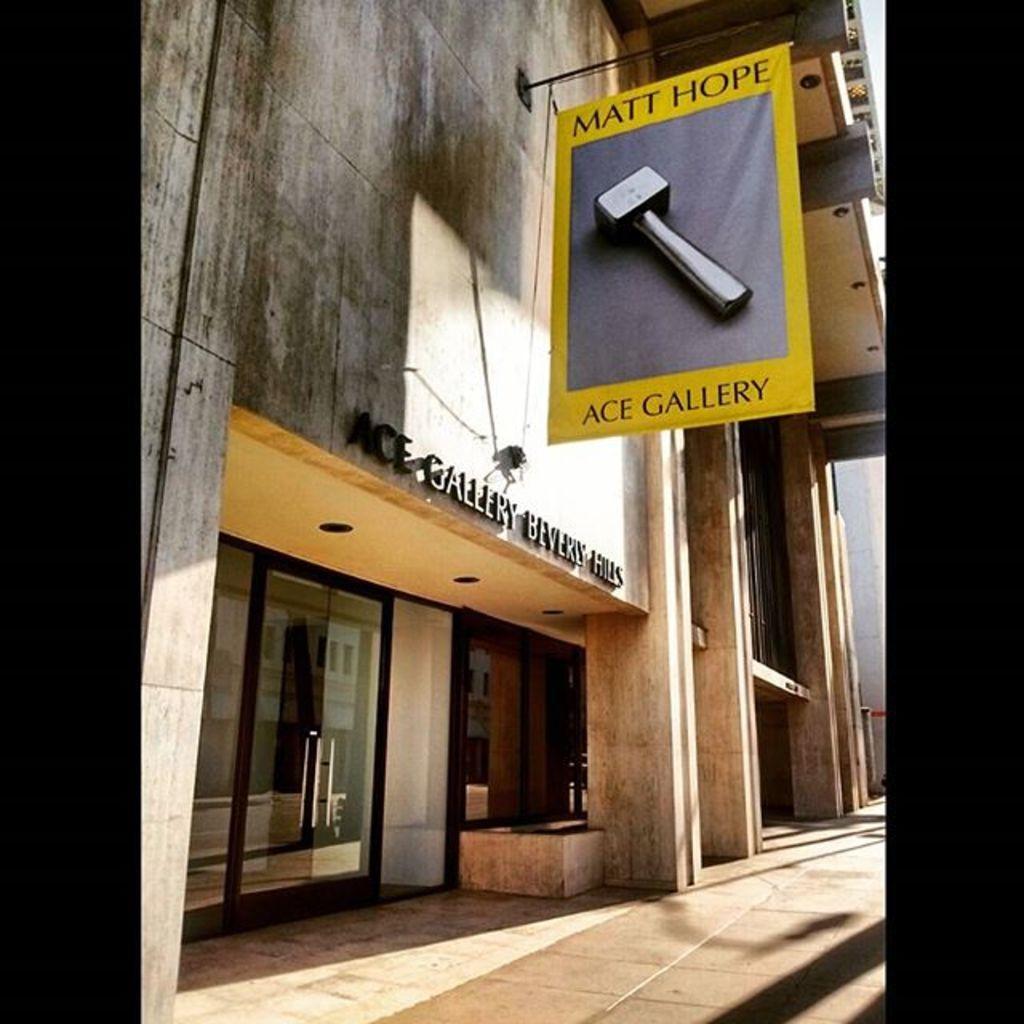In one or two sentences, can you explain what this image depicts? This is a building with glass door and handle. In-front of this building there is a banner of hammer. 